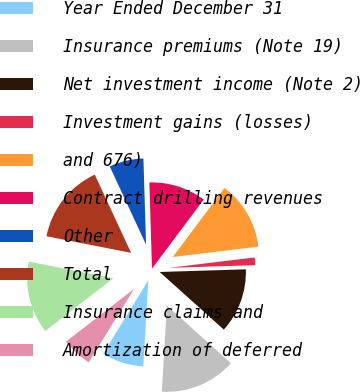<chart> <loc_0><loc_0><loc_500><loc_500><pie_chart><fcel>Year Ended December 31<fcel>Insurance premiums (Note 19)<fcel>Net investment income (Note 2)<fcel>Investment gains (losses)<fcel>and 676)<fcel>Contract drilling revenues<fcel>Other<fcel>Total<fcel>Insurance claims and<fcel>Amortization of deferred<nl><fcel>7.86%<fcel>14.28%<fcel>12.14%<fcel>1.43%<fcel>12.86%<fcel>10.71%<fcel>6.43%<fcel>15.0%<fcel>13.57%<fcel>5.72%<nl></chart> 